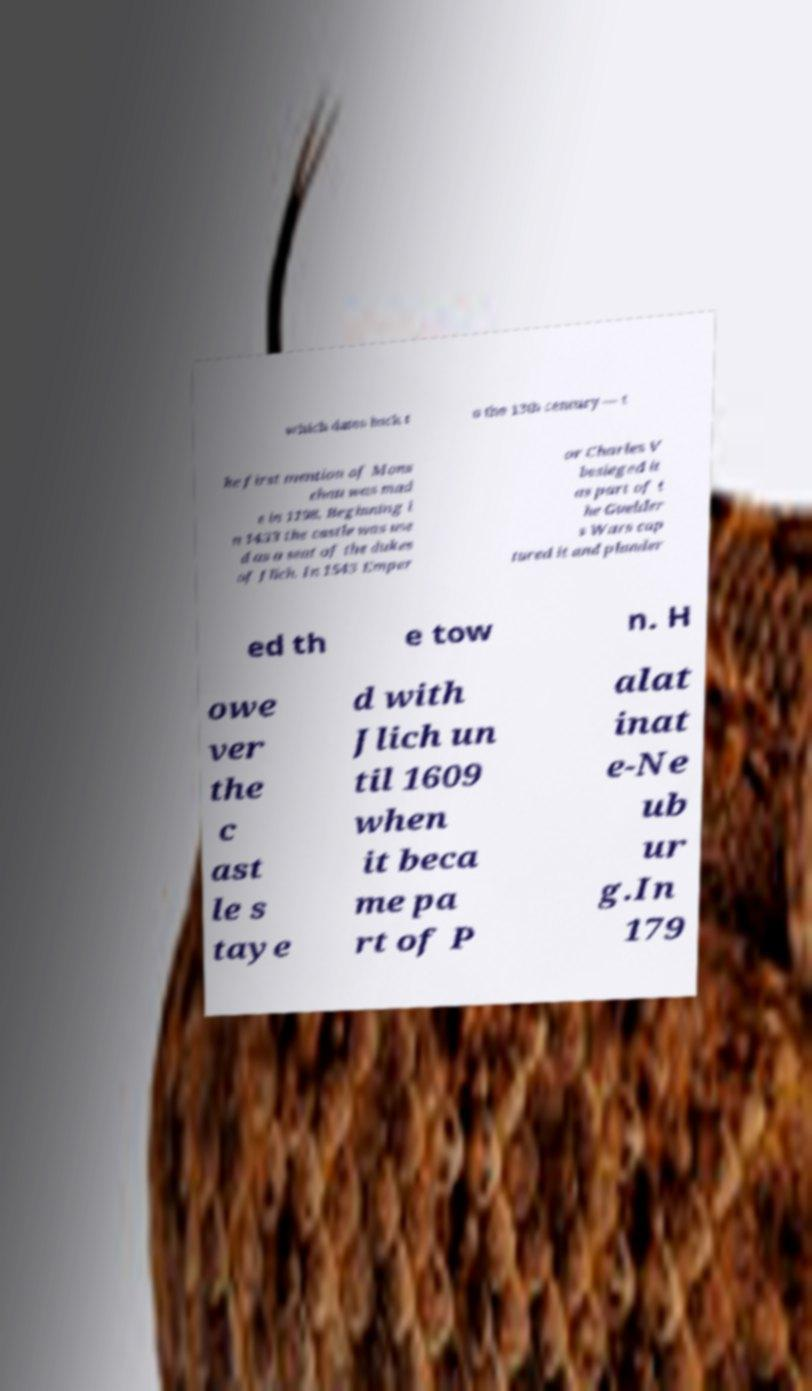I need the written content from this picture converted into text. Can you do that? which dates back t o the 13th century — t he first mention of Mons chau was mad e in 1198. Beginning i n 1433 the castle was use d as a seat of the dukes of Jlich. In 1543 Emper or Charles V besieged it as part of t he Guelder s Wars cap tured it and plunder ed th e tow n. H owe ver the c ast le s taye d with Jlich un til 1609 when it beca me pa rt of P alat inat e-Ne ub ur g.In 179 